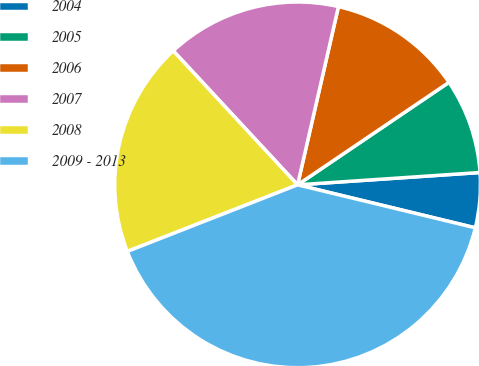Convert chart. <chart><loc_0><loc_0><loc_500><loc_500><pie_chart><fcel>2004<fcel>2005<fcel>2006<fcel>2007<fcel>2008<fcel>2009 - 2013<nl><fcel>4.85%<fcel>8.4%<fcel>11.94%<fcel>15.49%<fcel>19.03%<fcel>40.29%<nl></chart> 